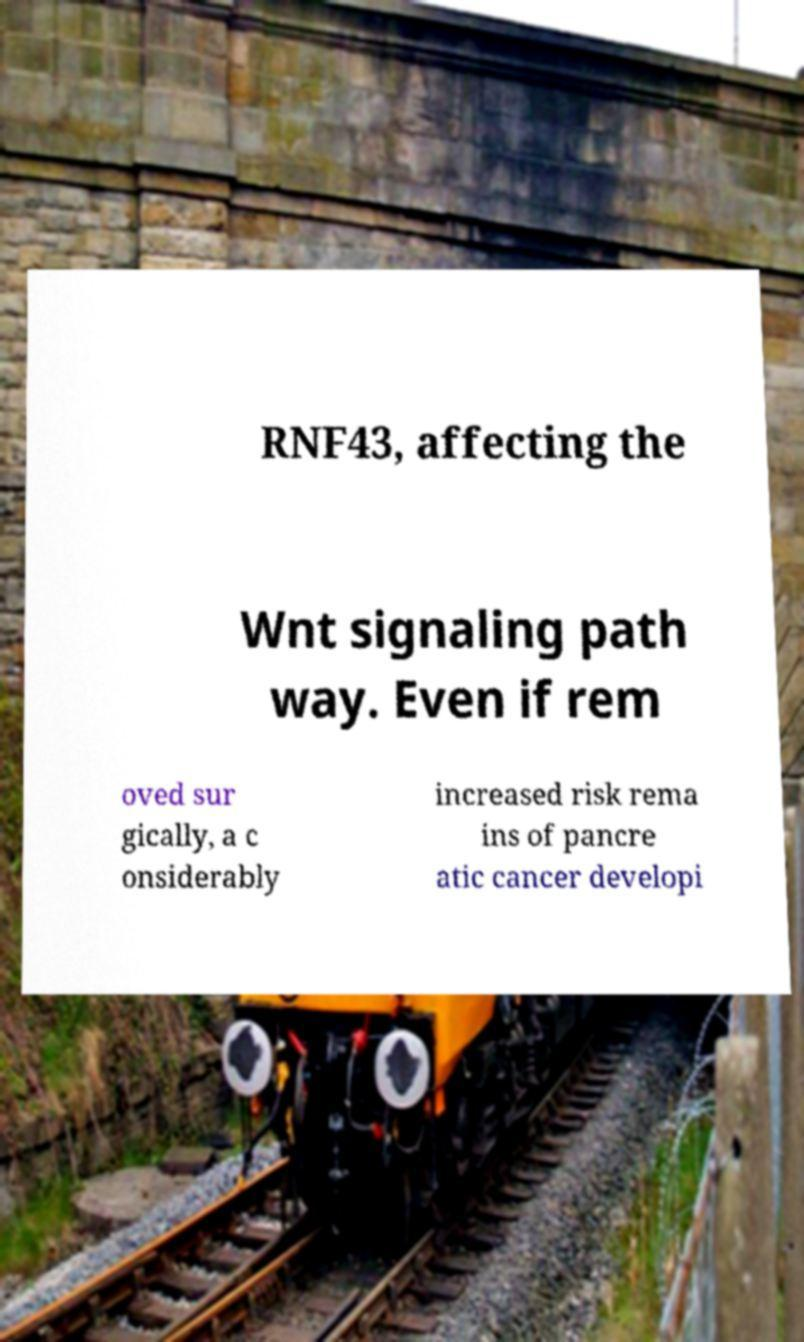For documentation purposes, I need the text within this image transcribed. Could you provide that? RNF43, affecting the Wnt signaling path way. Even if rem oved sur gically, a c onsiderably increased risk rema ins of pancre atic cancer developi 